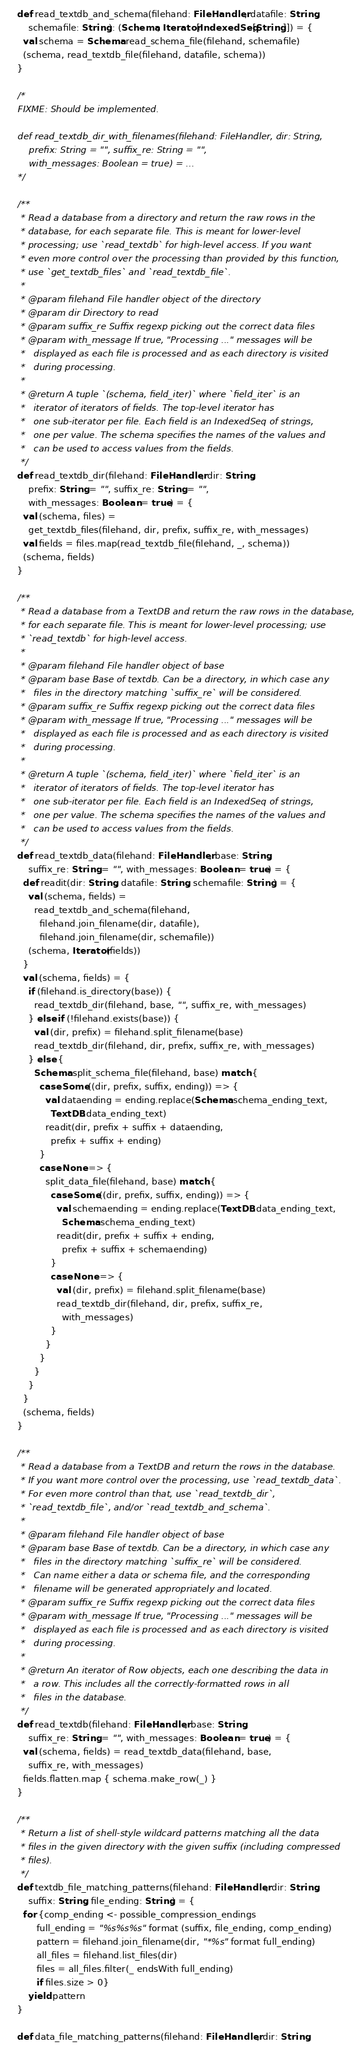<code> <loc_0><loc_0><loc_500><loc_500><_Scala_>    def read_textdb_and_schema(filehand: FileHandler, datafile: String,
        schemafile: String): (Schema, Iterator[IndexedSeq[String]]) = {
      val schema = Schema.read_schema_file(filehand, schemafile)
      (schema, read_textdb_file(filehand, datafile, schema))
    }

    /*
    FIXME: Should be implemented.

    def read_textdb_dir_with_filenames(filehand: FileHandler, dir: String,
        prefix: String = "", suffix_re: String = "",
        with_messages: Boolean = true) = ...
    */

    /**
     * Read a database from a directory and return the raw rows in the
     * database, for each separate file. This is meant for lower-level
     * processing; use `read_textdb` for high-level access. If you want
     * even more control over the processing than provided by this function,
     * use `get_textdb_files` and `read_textdb_file`.
     *
     * @param filehand File handler object of the directory
     * @param dir Directory to read
     * @param suffix_re Suffix regexp picking out the correct data files
     * @param with_message If true, "Processing ..." messages will be
     *   displayed as each file is processed and as each directory is visited
     *   during processing.
     *
     * @return A tuple `(schema, field_iter)` where `field_iter` is an
     *   iterator of iterators of fields. The top-level iterator has
     *   one sub-iterator per file. Each field is an IndexedSeq of strings,
     *   one per value. The schema specifies the names of the values and
     *   can be used to access values from the fields.
     */
    def read_textdb_dir(filehand: FileHandler, dir: String,
        prefix: String = "", suffix_re: String = "",
        with_messages: Boolean = true) = {
      val (schema, files) =
        get_textdb_files(filehand, dir, prefix, suffix_re, with_messages)
      val fields = files.map(read_textdb_file(filehand, _, schema))
      (schema, fields)
    }

    /**
     * Read a database from a TextDB and return the raw rows in the database,
     * for each separate file. This is meant for lower-level processing; use
     * `read_textdb` for high-level access.
     *
     * @param filehand File handler object of base
     * @param base Base of textdb. Can be a directory, in which case any
     *   files in the directory matching `suffix_re` will be considered.
     * @param suffix_re Suffix regexp picking out the correct data files
     * @param with_message If true, "Processing ..." messages will be
     *   displayed as each file is processed and as each directory is visited
     *   during processing.
     *
     * @return A tuple `(schema, field_iter)` where `field_iter` is an
     *   iterator of iterators of fields. The top-level iterator has
     *   one sub-iterator per file. Each field is an IndexedSeq of strings,
     *   one per value. The schema specifies the names of the values and
     *   can be used to access values from the fields.
     */
    def read_textdb_data(filehand: FileHandler, base: String,
        suffix_re: String = "", with_messages: Boolean = true) = {
      def readit(dir: String, datafile: String, schemafile: String) = {
        val (schema, fields) =
          read_textdb_and_schema(filehand,
            filehand.join_filename(dir, datafile),
            filehand.join_filename(dir, schemafile))
        (schema, Iterator(fields))
      }
      val (schema, fields) = {
        if (filehand.is_directory(base)) {
          read_textdb_dir(filehand, base, "", suffix_re, with_messages)
        } else if (!filehand.exists(base)) {
          val (dir, prefix) = filehand.split_filename(base)
          read_textdb_dir(filehand, dir, prefix, suffix_re, with_messages)
        } else {
          Schema.split_schema_file(filehand, base) match {
            case Some((dir, prefix, suffix, ending)) => {
              val dataending = ending.replace(Schema.schema_ending_text,
                TextDB.data_ending_text)
              readit(dir, prefix + suffix + dataending,
                prefix + suffix + ending)
            }
            case None => {
              split_data_file(filehand, base) match {
                case Some((dir, prefix, suffix, ending)) => {
                  val schemaending = ending.replace(TextDB.data_ending_text,
                    Schema.schema_ending_text)
                  readit(dir, prefix + suffix + ending,
                    prefix + suffix + schemaending)
                }
                case None => {
                  val (dir, prefix) = filehand.split_filename(base)
                  read_textdb_dir(filehand, dir, prefix, suffix_re,
                    with_messages)
                }
              }
            }
          }
        }
      }
      (schema, fields)
    }

    /**
     * Read a database from a TextDB and return the rows in the database.
     * If you want more control over the processing, use `read_textdb_data`.
     * For even more control than that, use `read_textdb_dir`,
     * `read_textdb_file`, and/or `read_textdb_and_schema`.
     *
     * @param filehand File handler object of base
     * @param base Base of textdb. Can be a directory, in which case any
     *   files in the directory matching `suffix_re` will be considered.
     *   Can name either a data or schema file, and the corresponding
     *   filename will be generated appropriately and located.
     * @param suffix_re Suffix regexp picking out the correct data files
     * @param with_message If true, "Processing ..." messages will be
     *   displayed as each file is processed and as each directory is visited
     *   during processing.
     *
     * @return An iterator of Row objects, each one describing the data in
     *   a row. This includes all the correctly-formatted rows in all
     *   files in the database.
     */
    def read_textdb(filehand: FileHandler, base: String,
        suffix_re: String = "", with_messages: Boolean = true) = {
      val (schema, fields) = read_textdb_data(filehand, base,
        suffix_re, with_messages)
      fields.flatten.map { schema.make_row(_) }
    }

    /**
     * Return a list of shell-style wildcard patterns matching all the data
     * files in the given directory with the given suffix (including compressed
     * files).
     */
    def textdb_file_matching_patterns(filehand: FileHandler, dir: String,
        suffix: String, file_ending: String) = {
      for {comp_ending <- possible_compression_endings
           full_ending = "%s%s%s" format (suffix, file_ending, comp_ending)
           pattern = filehand.join_filename(dir, "*%s" format full_ending)
           all_files = filehand.list_files(dir)
           files = all_files.filter(_ endsWith full_ending)
           if files.size > 0}
        yield pattern
    }

    def data_file_matching_patterns(filehand: FileHandler, dir: String,</code> 